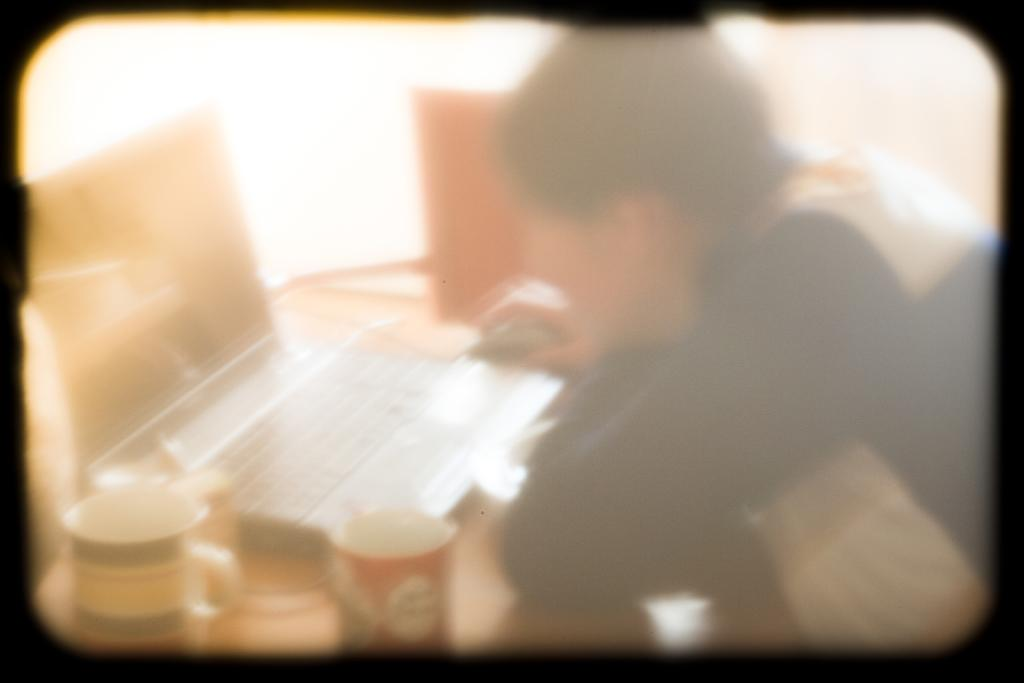Who or what is in the image? There is a person in the image. What is the person doing in the image? The person is sitting in front of a table. What can be seen on the table in the image? There are cups, a laptop, a mouse, and other unspecified objects on the table. What type of pig is present in the image? There is no pig present in the image. What belief system does the person in the image follow? There is no information about the person's belief system in the image. 